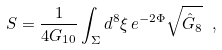<formula> <loc_0><loc_0><loc_500><loc_500>S = \frac { 1 } { 4 G _ { 1 0 } } \int _ { \Sigma } d ^ { 8 } \xi \, e ^ { - 2 \Phi } \sqrt { \hat { G } _ { 8 } } \ ,</formula> 